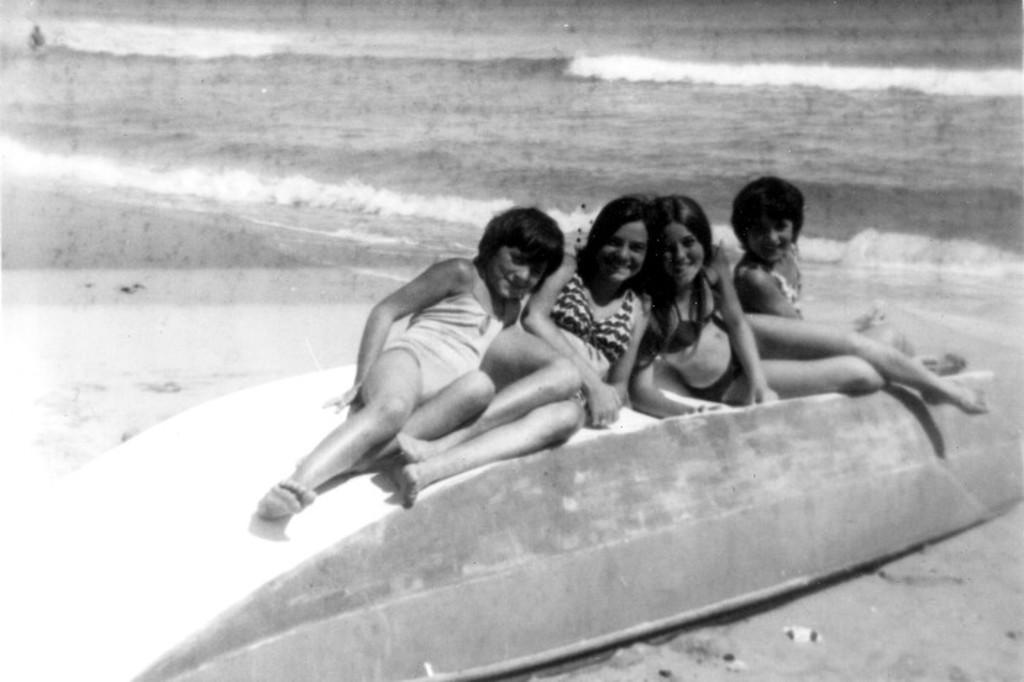How many people are present in the image? There are four women sitting in the image. What can be seen in the background of the image? There is water visible in the background of the image. What is the color scheme of the image? The image is black and white. What type of soda is being served to the women in the image? There is no soda present in the image; it is a black and white image of four women sitting. Can you tell me which woman is the judge in the image? There is no indication of a judge or any legal proceedings in the image; it simply shows four women sitting. 